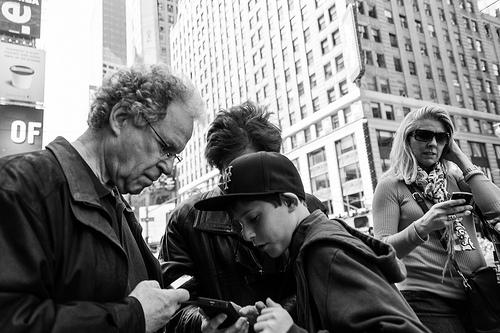Question: when was this photo taken?
Choices:
A. Night.
B. Daytime.
C. Halloween.
D. Christmas.
Answer with the letter. Answer: B Question: why are the two people in left foreground looking down?
Choices:
A. Checking the gorund.
B. Looking at cell phones.
C. Reading a book.
D. Checking a map.
Answer with the letter. Answer: B Question: what is seen in background on right in photo?
Choices:
A. Tree.
B. Mountain.
C. Building.
D. Cloud.
Answer with the letter. Answer: C Question: what location was this photo taken in?
Choices:
A. City.
B. Country.
C. Swamp.
D. Zoo.
Answer with the letter. Answer: A Question: what type of building could the building in background on right be?
Choices:
A. Apartments.
B. Bank.
C. Office building.
D. School.
Answer with the letter. Answer: C Question: where is the blonde woman's cell phone located?
Choices:
A. In her right hand.
B. Her left hand.
C. Her purse.
D. At home.
Answer with the letter. Answer: A 